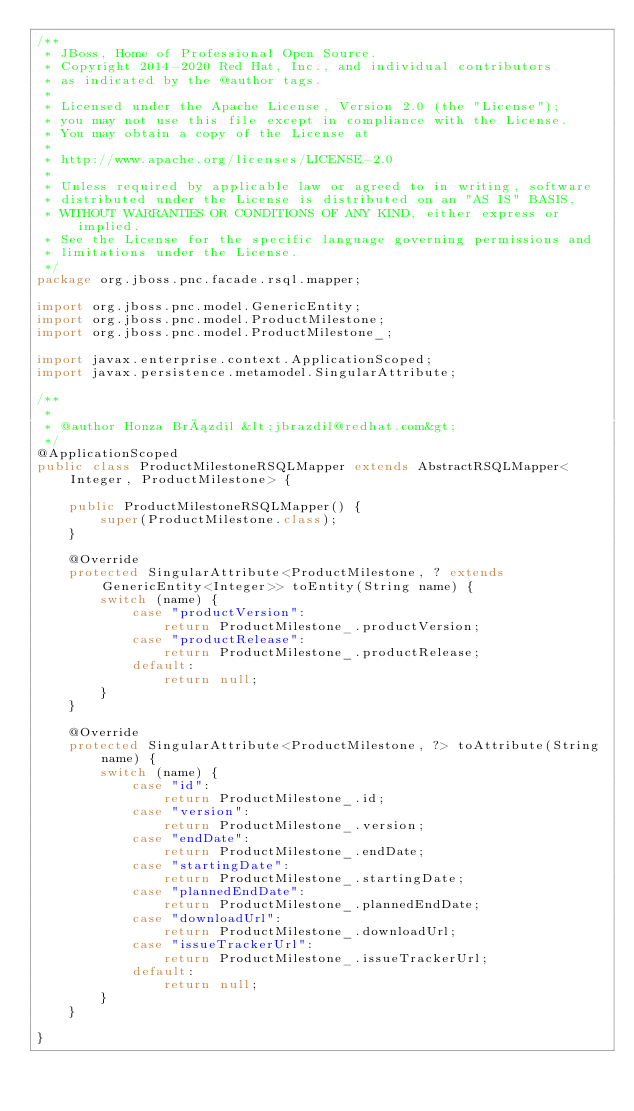<code> <loc_0><loc_0><loc_500><loc_500><_Java_>/**
 * JBoss, Home of Professional Open Source.
 * Copyright 2014-2020 Red Hat, Inc., and individual contributors
 * as indicated by the @author tags.
 *
 * Licensed under the Apache License, Version 2.0 (the "License");
 * you may not use this file except in compliance with the License.
 * You may obtain a copy of the License at
 *
 * http://www.apache.org/licenses/LICENSE-2.0
 *
 * Unless required by applicable law or agreed to in writing, software
 * distributed under the License is distributed on an "AS IS" BASIS,
 * WITHOUT WARRANTIES OR CONDITIONS OF ANY KIND, either express or implied.
 * See the License for the specific language governing permissions and
 * limitations under the License.
 */
package org.jboss.pnc.facade.rsql.mapper;

import org.jboss.pnc.model.GenericEntity;
import org.jboss.pnc.model.ProductMilestone;
import org.jboss.pnc.model.ProductMilestone_;

import javax.enterprise.context.ApplicationScoped;
import javax.persistence.metamodel.SingularAttribute;

/**
 *
 * @author Honza Brázdil &lt;jbrazdil@redhat.com&gt;
 */
@ApplicationScoped
public class ProductMilestoneRSQLMapper extends AbstractRSQLMapper<Integer, ProductMilestone> {

    public ProductMilestoneRSQLMapper() {
        super(ProductMilestone.class);
    }

    @Override
    protected SingularAttribute<ProductMilestone, ? extends GenericEntity<Integer>> toEntity(String name) {
        switch (name) {
            case "productVersion":
                return ProductMilestone_.productVersion;
            case "productRelease":
                return ProductMilestone_.productRelease;
            default:
                return null;
        }
    }

    @Override
    protected SingularAttribute<ProductMilestone, ?> toAttribute(String name) {
        switch (name) {
            case "id":
                return ProductMilestone_.id;
            case "version":
                return ProductMilestone_.version;
            case "endDate":
                return ProductMilestone_.endDate;
            case "startingDate":
                return ProductMilestone_.startingDate;
            case "plannedEndDate":
                return ProductMilestone_.plannedEndDate;
            case "downloadUrl":
                return ProductMilestone_.downloadUrl;
            case "issueTrackerUrl":
                return ProductMilestone_.issueTrackerUrl;
            default:
                return null;
        }
    }

}
</code> 